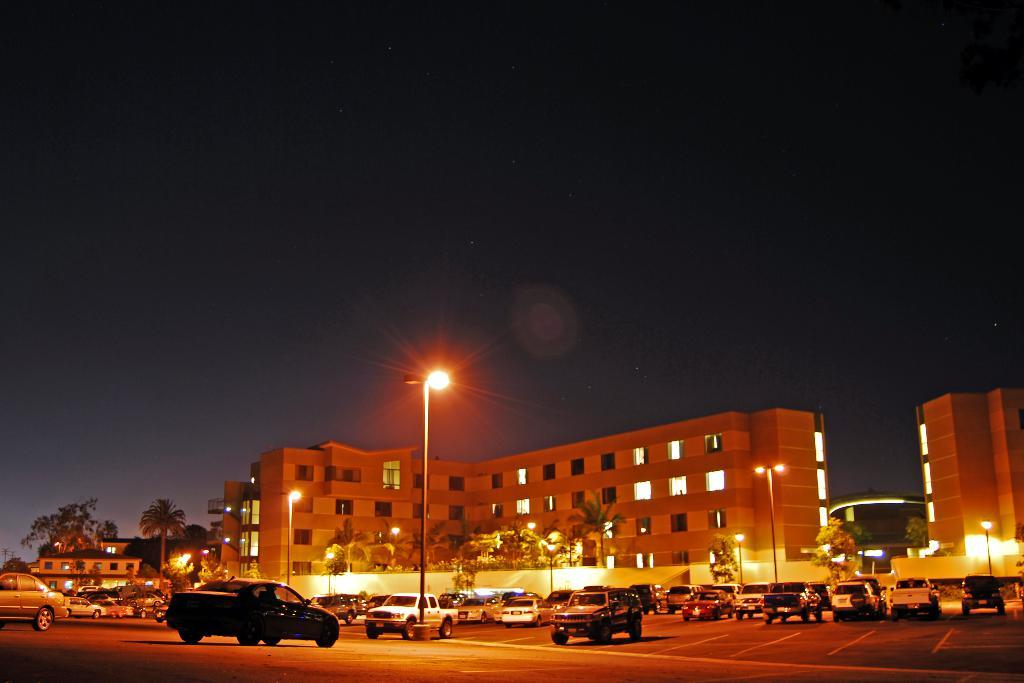What can be seen in the image related to transportation? There are cars parked in the image. Where are the cars located in the image? The cars are in a parking place. What can be seen in the background of the image? There are trees and buildings in the background of the image. Can you describe the kitty playing with the zephyr on the land in the image? There is no kitty, zephyr, or land present in the image; it features parked cars in a parking place with trees and buildings in the background. 